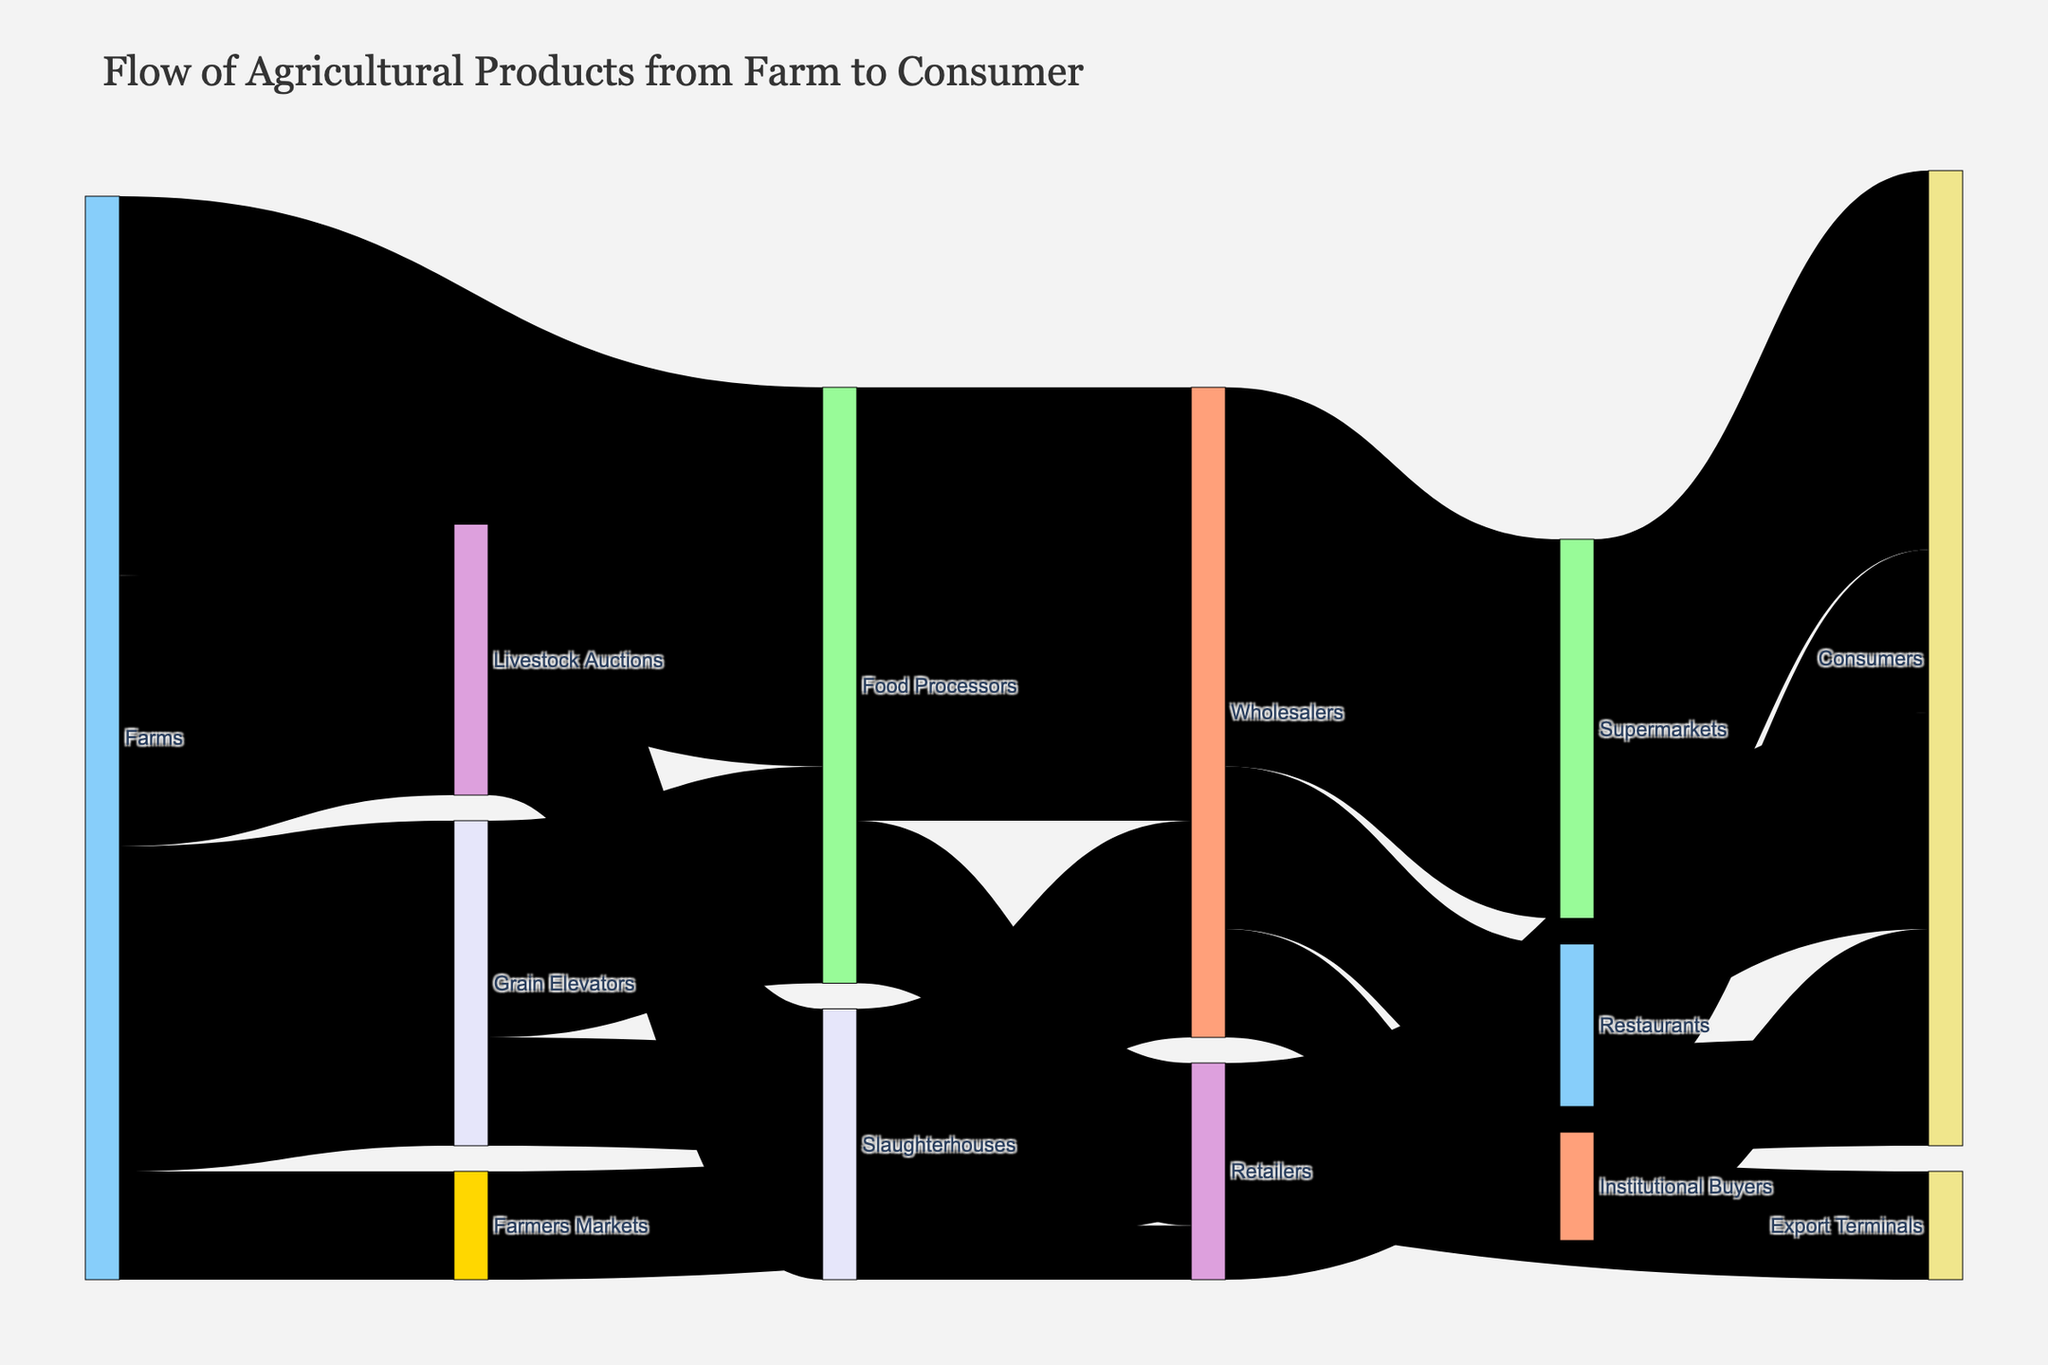What is the title of the figure? The title is displayed at the top center of the figure and reads "Flow of Agricultural Products from Farm to Consumer". This title helps to understand the overall theme of the data being visualized.
Answer: Flow of Agricultural Products from Farm to Consumer How many different nodes are involved in the Sankey diagram? The nodes represent unique entities or stages in the flow of agricultural products. By counting all distinct labels in the figure, we can determine the number of nodes.
Answer: 13 Which node has the highest value of incoming flow, and what is that value? Identify the node with the greatest total value coming into it. For each node, sum the values of all flows directed toward it and compare these sums. Supermarkets have the highest incoming flow, with flows of 35 from Wholesalers.
Answer: Supermarkets, 35 Which route sends the largest amount of agricultural products to Wholesalers? Look at the arrows pointing to Wholesalers and compare the values. The largest amount comes from Food Processors with a value of 40.
Answer: Food Processors What is the total value of agricultural products flowing directly from Slaughterhouses? Sum the values of all flows originating from Slaughterhouses. The flows are to Wholesalers (20) and Retailers (5), giving a total of 25.
Answer: 25 What percentage of the products from Farms go to Grain Elevators? First, find the value of the flow from Farms to Grain Elevators (30) and the total value originating from Farms (30 + 25 + 10 + 35 = 100). Then, calculate the percentage (30/100 * 100%).
Answer: 30% Which distribution channel sends the largest amount of products directly to Consumers? Compare the values for routes ending at Consumers. Supermarkets send the largest amount directly to Consumers, with a value of 35.
Answer: Supermarkets What is the difference between the total values flowing to Retailers and to Wholesalers from Food Processors? Identify and sum the flows from Food Processors to Retailers (15) and to Wholesalers (40). The difference is calculated as 40 - 15.
Answer: 25 How many pathways lead from Food Processors to the Consumers, directly or indirectly? To count pathways, trace all routes originating from Food Processors to Consumers. There are three: Food Processors → Retailers → Consumers, Food Processors → Wholesalers → Supermarkets → Consumers, and Food Processors → Wholesalers → Restaurants → Consumers.
Answer: 3 